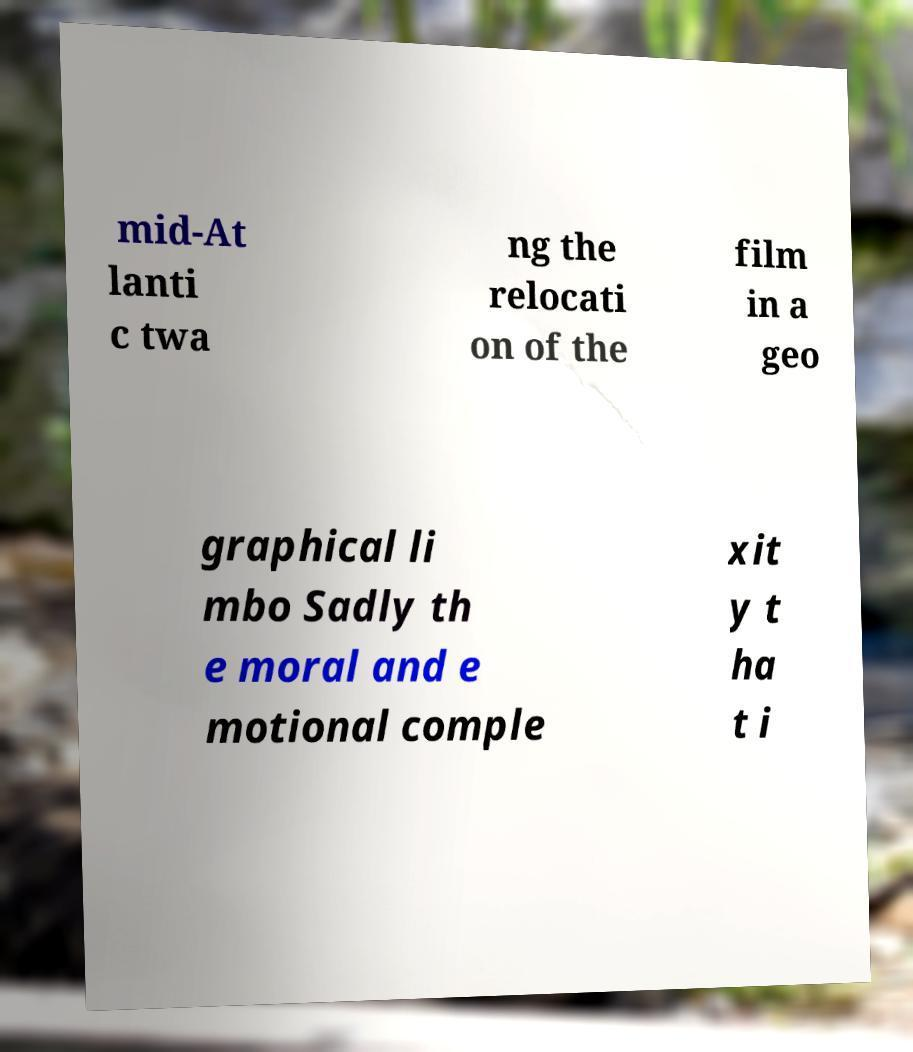There's text embedded in this image that I need extracted. Can you transcribe it verbatim? mid-At lanti c twa ng the relocati on of the film in a geo graphical li mbo Sadly th e moral and e motional comple xit y t ha t i 